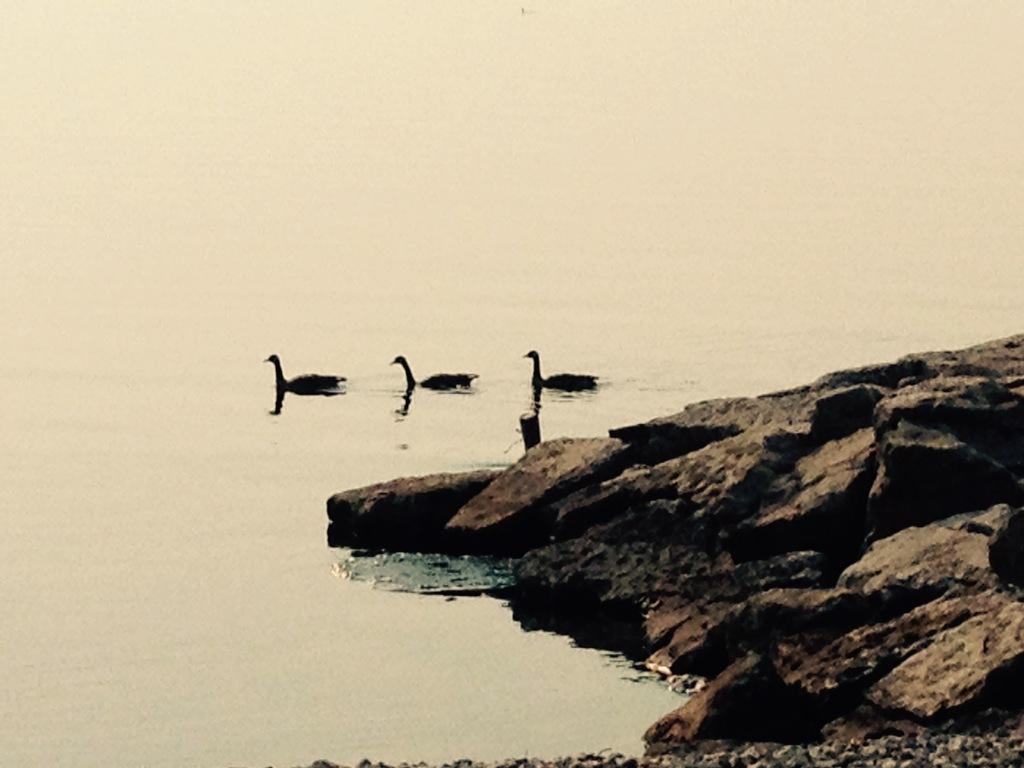How many birds can be seen in the image? There are three birds in the image. Where are the birds located? The birds are in the water. What is visible in the image besides the birds? There is water and stones visible in the image. What type of instrument is the bear playing in the image? There is no bear or instrument present in the image. 